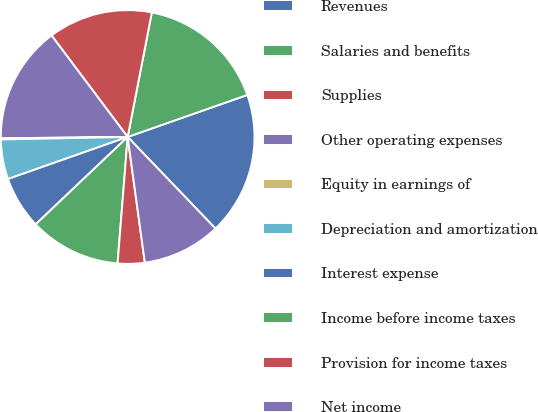<chart> <loc_0><loc_0><loc_500><loc_500><pie_chart><fcel>Revenues<fcel>Salaries and benefits<fcel>Supplies<fcel>Other operating expenses<fcel>Equity in earnings of<fcel>Depreciation and amortization<fcel>Interest expense<fcel>Income before income taxes<fcel>Provision for income taxes<fcel>Net income<nl><fcel>18.21%<fcel>16.57%<fcel>13.29%<fcel>14.93%<fcel>0.14%<fcel>5.07%<fcel>6.71%<fcel>11.64%<fcel>3.43%<fcel>10.0%<nl></chart> 